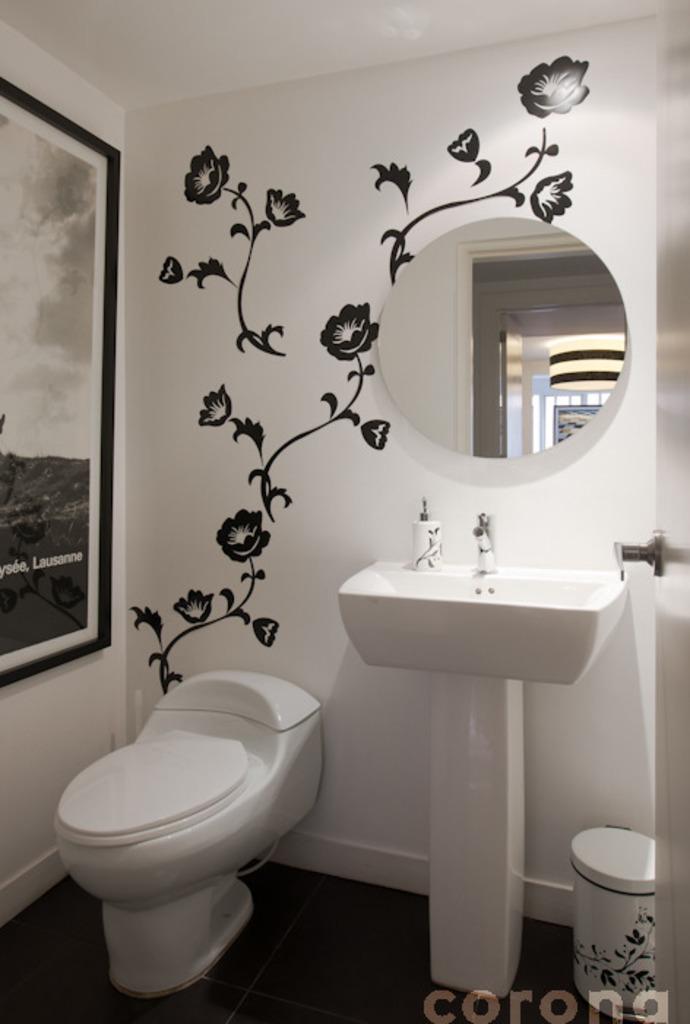Describe this image in one or two sentences. This is the picture of a room. In this image there is a floral design and there is a mirror and frame on the wall and there is text on the frame. There is a wash basin and toilet seat and dustbin. On the right side of the image there is a door. At the bottom there is a floor and at the bottom right there is text and there is a reflection of door and frame on the mirror. 